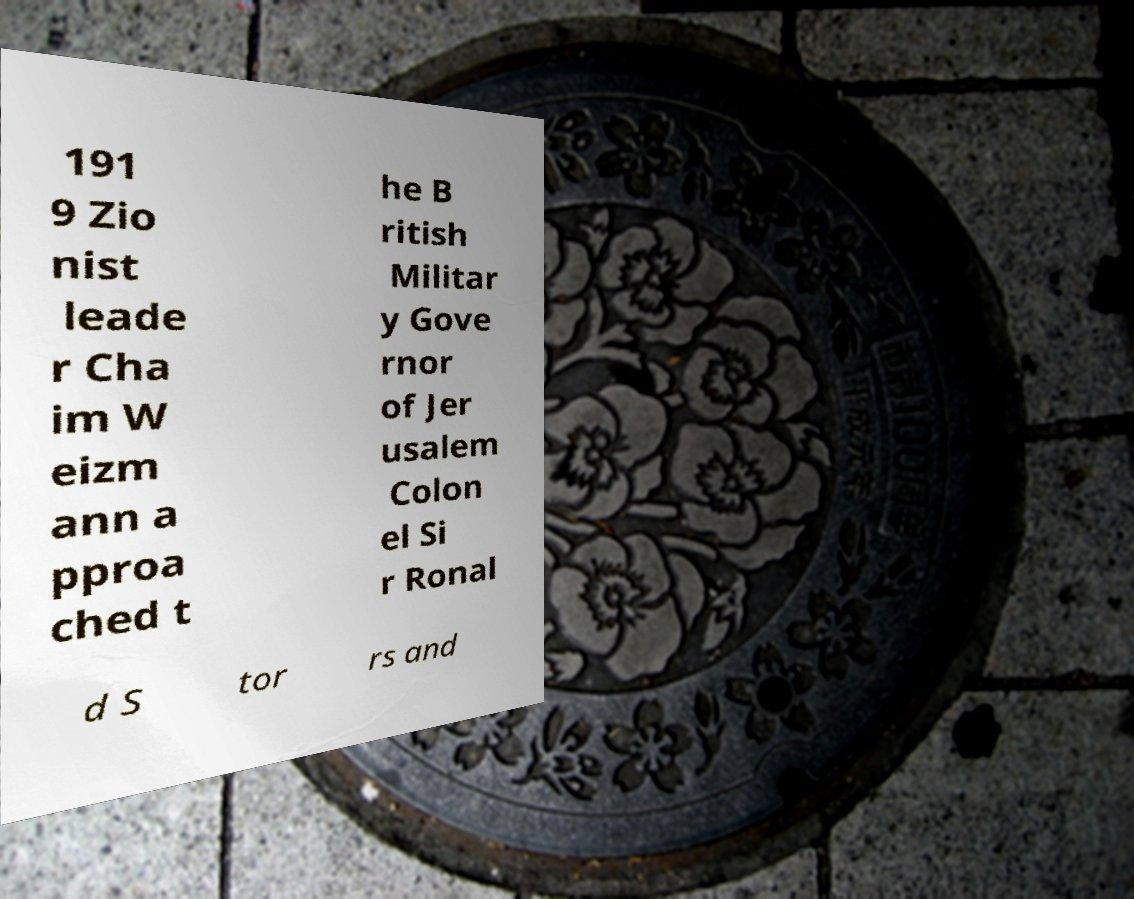Could you extract and type out the text from this image? 191 9 Zio nist leade r Cha im W eizm ann a pproa ched t he B ritish Militar y Gove rnor of Jer usalem Colon el Si r Ronal d S tor rs and 